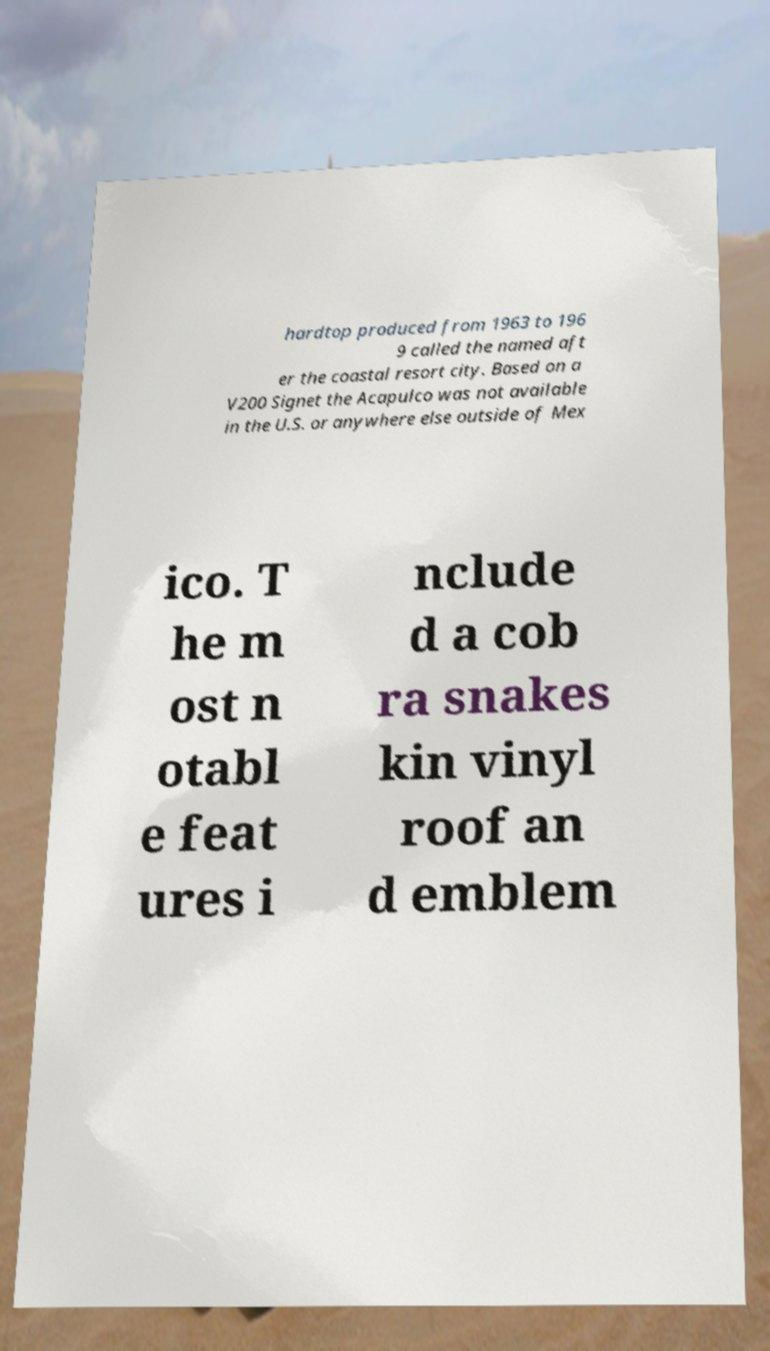Can you accurately transcribe the text from the provided image for me? hardtop produced from 1963 to 196 9 called the named aft er the coastal resort city. Based on a V200 Signet the Acapulco was not available in the U.S. or anywhere else outside of Mex ico. T he m ost n otabl e feat ures i nclude d a cob ra snakes kin vinyl roof an d emblem 